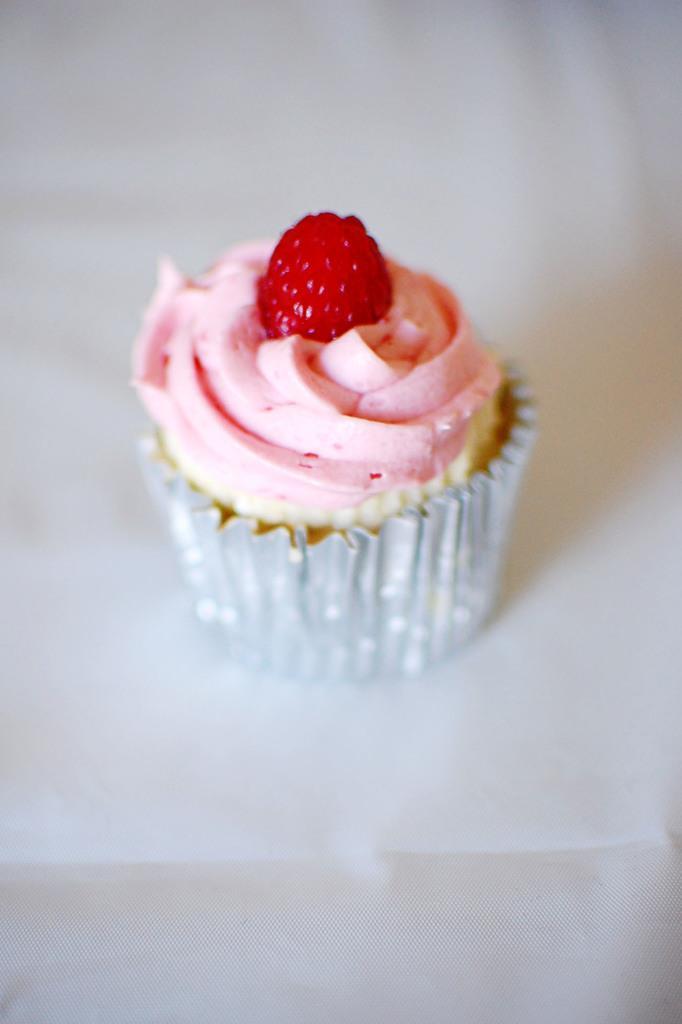What type of dessert is featured in the image? There is a raspberry cupcake in the image. Where is the cupcake located? The cupcake is on a table. What is the outcome of the trade between the cupcake and the table in the image? There is no trade happening in the image; the cupcake is simply placed on the table. 